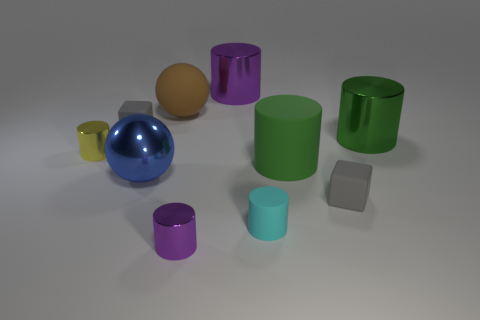There is a purple metal object that is behind the brown ball; is its size the same as the rubber sphere?
Provide a succinct answer. Yes. What number of other objects are the same shape as the large brown thing?
Give a very brief answer. 1. Do the tiny matte cube that is to the right of the brown sphere and the large metallic ball have the same color?
Offer a very short reply. No. Is there a tiny metal cylinder of the same color as the big rubber cylinder?
Keep it short and to the point. No. There is a large purple cylinder; what number of purple things are to the right of it?
Give a very brief answer. 0. How many other objects are the same size as the cyan cylinder?
Give a very brief answer. 4. Is the ball that is in front of the tiny yellow metallic object made of the same material as the gray object that is right of the large purple cylinder?
Your answer should be very brief. No. There is a matte cylinder that is the same size as the blue sphere; what color is it?
Keep it short and to the point. Green. Are there any other things that have the same color as the rubber ball?
Give a very brief answer. No. There is a gray matte cube behind the large cylinder right of the matte block that is right of the big purple shiny cylinder; how big is it?
Provide a short and direct response. Small. 